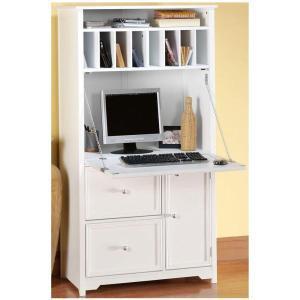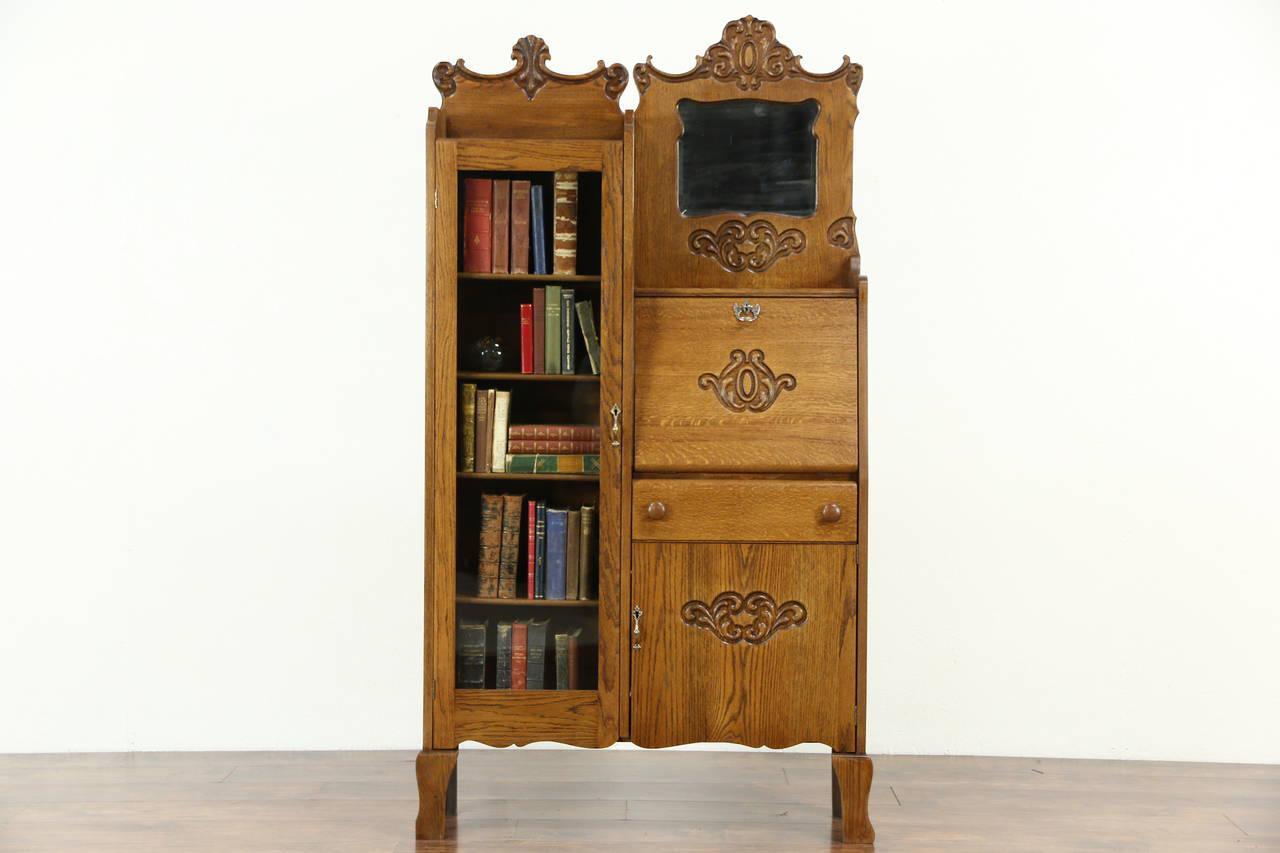The first image is the image on the left, the second image is the image on the right. Given the left and right images, does the statement "The hutch has side by side doors with window panels." hold true? Answer yes or no. No. The first image is the image on the left, the second image is the image on the right. For the images displayed, is the sentence "there is a cabinet with a glass door n the left and a mirror and 3 drawers on the right" factually correct? Answer yes or no. No. 